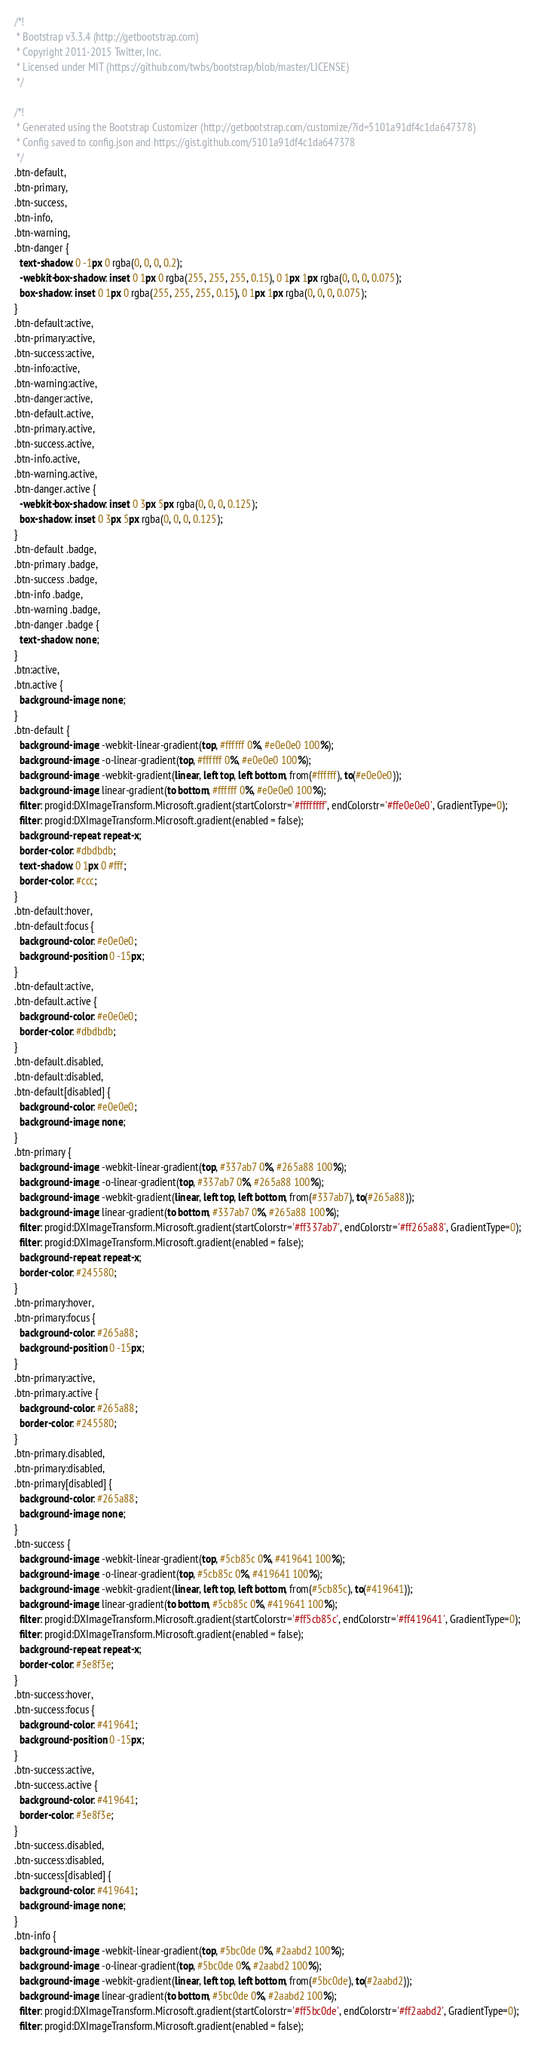<code> <loc_0><loc_0><loc_500><loc_500><_CSS_>/*!
 * Bootstrap v3.3.4 (http://getbootstrap.com)
 * Copyright 2011-2015 Twitter, Inc.
 * Licensed under MIT (https://github.com/twbs/bootstrap/blob/master/LICENSE)
 */

/*!
 * Generated using the Bootstrap Customizer (http://getbootstrap.com/customize/?id=5101a91df4c1da647378)
 * Config saved to config.json and https://gist.github.com/5101a91df4c1da647378
 */
.btn-default,
.btn-primary,
.btn-success,
.btn-info,
.btn-warning,
.btn-danger {
  text-shadow: 0 -1px 0 rgba(0, 0, 0, 0.2);
  -webkit-box-shadow: inset 0 1px 0 rgba(255, 255, 255, 0.15), 0 1px 1px rgba(0, 0, 0, 0.075);
  box-shadow: inset 0 1px 0 rgba(255, 255, 255, 0.15), 0 1px 1px rgba(0, 0, 0, 0.075);
}
.btn-default:active,
.btn-primary:active,
.btn-success:active,
.btn-info:active,
.btn-warning:active,
.btn-danger:active,
.btn-default.active,
.btn-primary.active,
.btn-success.active,
.btn-info.active,
.btn-warning.active,
.btn-danger.active {
  -webkit-box-shadow: inset 0 3px 5px rgba(0, 0, 0, 0.125);
  box-shadow: inset 0 3px 5px rgba(0, 0, 0, 0.125);
}
.btn-default .badge,
.btn-primary .badge,
.btn-success .badge,
.btn-info .badge,
.btn-warning .badge,
.btn-danger .badge {
  text-shadow: none;
}
.btn:active,
.btn.active {
  background-image: none;
}
.btn-default {
  background-image: -webkit-linear-gradient(top, #ffffff 0%, #e0e0e0 100%);
  background-image: -o-linear-gradient(top, #ffffff 0%, #e0e0e0 100%);
  background-image: -webkit-gradient(linear, left top, left bottom, from(#ffffff), to(#e0e0e0));
  background-image: linear-gradient(to bottom, #ffffff 0%, #e0e0e0 100%);
  filter: progid:DXImageTransform.Microsoft.gradient(startColorstr='#ffffffff', endColorstr='#ffe0e0e0', GradientType=0);
  filter: progid:DXImageTransform.Microsoft.gradient(enabled = false);
  background-repeat: repeat-x;
  border-color: #dbdbdb;
  text-shadow: 0 1px 0 #fff;
  border-color: #ccc;
}
.btn-default:hover,
.btn-default:focus {
  background-color: #e0e0e0;
  background-position: 0 -15px;
}
.btn-default:active,
.btn-default.active {
  background-color: #e0e0e0;
  border-color: #dbdbdb;
}
.btn-default.disabled,
.btn-default:disabled,
.btn-default[disabled] {
  background-color: #e0e0e0;
  background-image: none;
}
.btn-primary {
  background-image: -webkit-linear-gradient(top, #337ab7 0%, #265a88 100%);
  background-image: -o-linear-gradient(top, #337ab7 0%, #265a88 100%);
  background-image: -webkit-gradient(linear, left top, left bottom, from(#337ab7), to(#265a88));
  background-image: linear-gradient(to bottom, #337ab7 0%, #265a88 100%);
  filter: progid:DXImageTransform.Microsoft.gradient(startColorstr='#ff337ab7', endColorstr='#ff265a88', GradientType=0);
  filter: progid:DXImageTransform.Microsoft.gradient(enabled = false);
  background-repeat: repeat-x;
  border-color: #245580;
}
.btn-primary:hover,
.btn-primary:focus {
  background-color: #265a88;
  background-position: 0 -15px;
}
.btn-primary:active,
.btn-primary.active {
  background-color: #265a88;
  border-color: #245580;
}
.btn-primary.disabled,
.btn-primary:disabled,
.btn-primary[disabled] {
  background-color: #265a88;
  background-image: none;
}
.btn-success {
  background-image: -webkit-linear-gradient(top, #5cb85c 0%, #419641 100%);
  background-image: -o-linear-gradient(top, #5cb85c 0%, #419641 100%);
  background-image: -webkit-gradient(linear, left top, left bottom, from(#5cb85c), to(#419641));
  background-image: linear-gradient(to bottom, #5cb85c 0%, #419641 100%);
  filter: progid:DXImageTransform.Microsoft.gradient(startColorstr='#ff5cb85c', endColorstr='#ff419641', GradientType=0);
  filter: progid:DXImageTransform.Microsoft.gradient(enabled = false);
  background-repeat: repeat-x;
  border-color: #3e8f3e;
}
.btn-success:hover,
.btn-success:focus {
  background-color: #419641;
  background-position: 0 -15px;
}
.btn-success:active,
.btn-success.active {
  background-color: #419641;
  border-color: #3e8f3e;
}
.btn-success.disabled,
.btn-success:disabled,
.btn-success[disabled] {
  background-color: #419641;
  background-image: none;
}
.btn-info {
  background-image: -webkit-linear-gradient(top, #5bc0de 0%, #2aabd2 100%);
  background-image: -o-linear-gradient(top, #5bc0de 0%, #2aabd2 100%);
  background-image: -webkit-gradient(linear, left top, left bottom, from(#5bc0de), to(#2aabd2));
  background-image: linear-gradient(to bottom, #5bc0de 0%, #2aabd2 100%);
  filter: progid:DXImageTransform.Microsoft.gradient(startColorstr='#ff5bc0de', endColorstr='#ff2aabd2', GradientType=0);
  filter: progid:DXImageTransform.Microsoft.gradient(enabled = false);</code> 